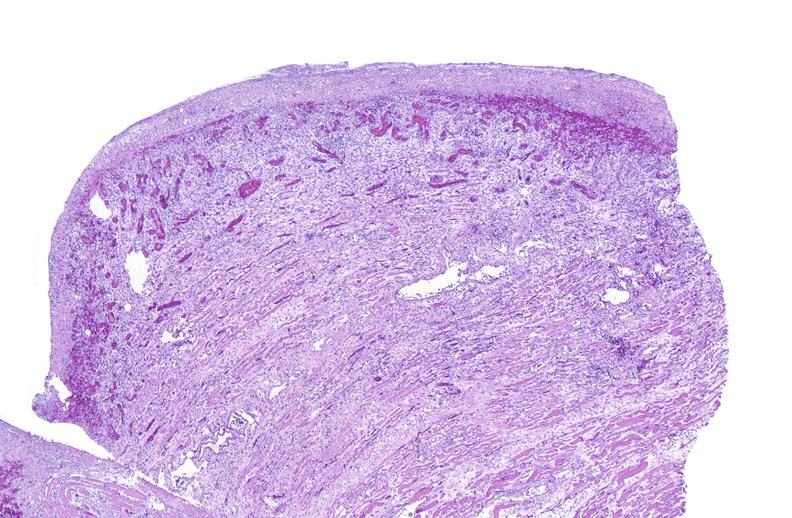what does this image show?
Answer the question using a single word or phrase. Tracheotomy 